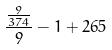Convert formula to latex. <formula><loc_0><loc_0><loc_500><loc_500>\frac { \frac { 9 } { 3 7 4 } } { 9 } - 1 + 2 6 5</formula> 